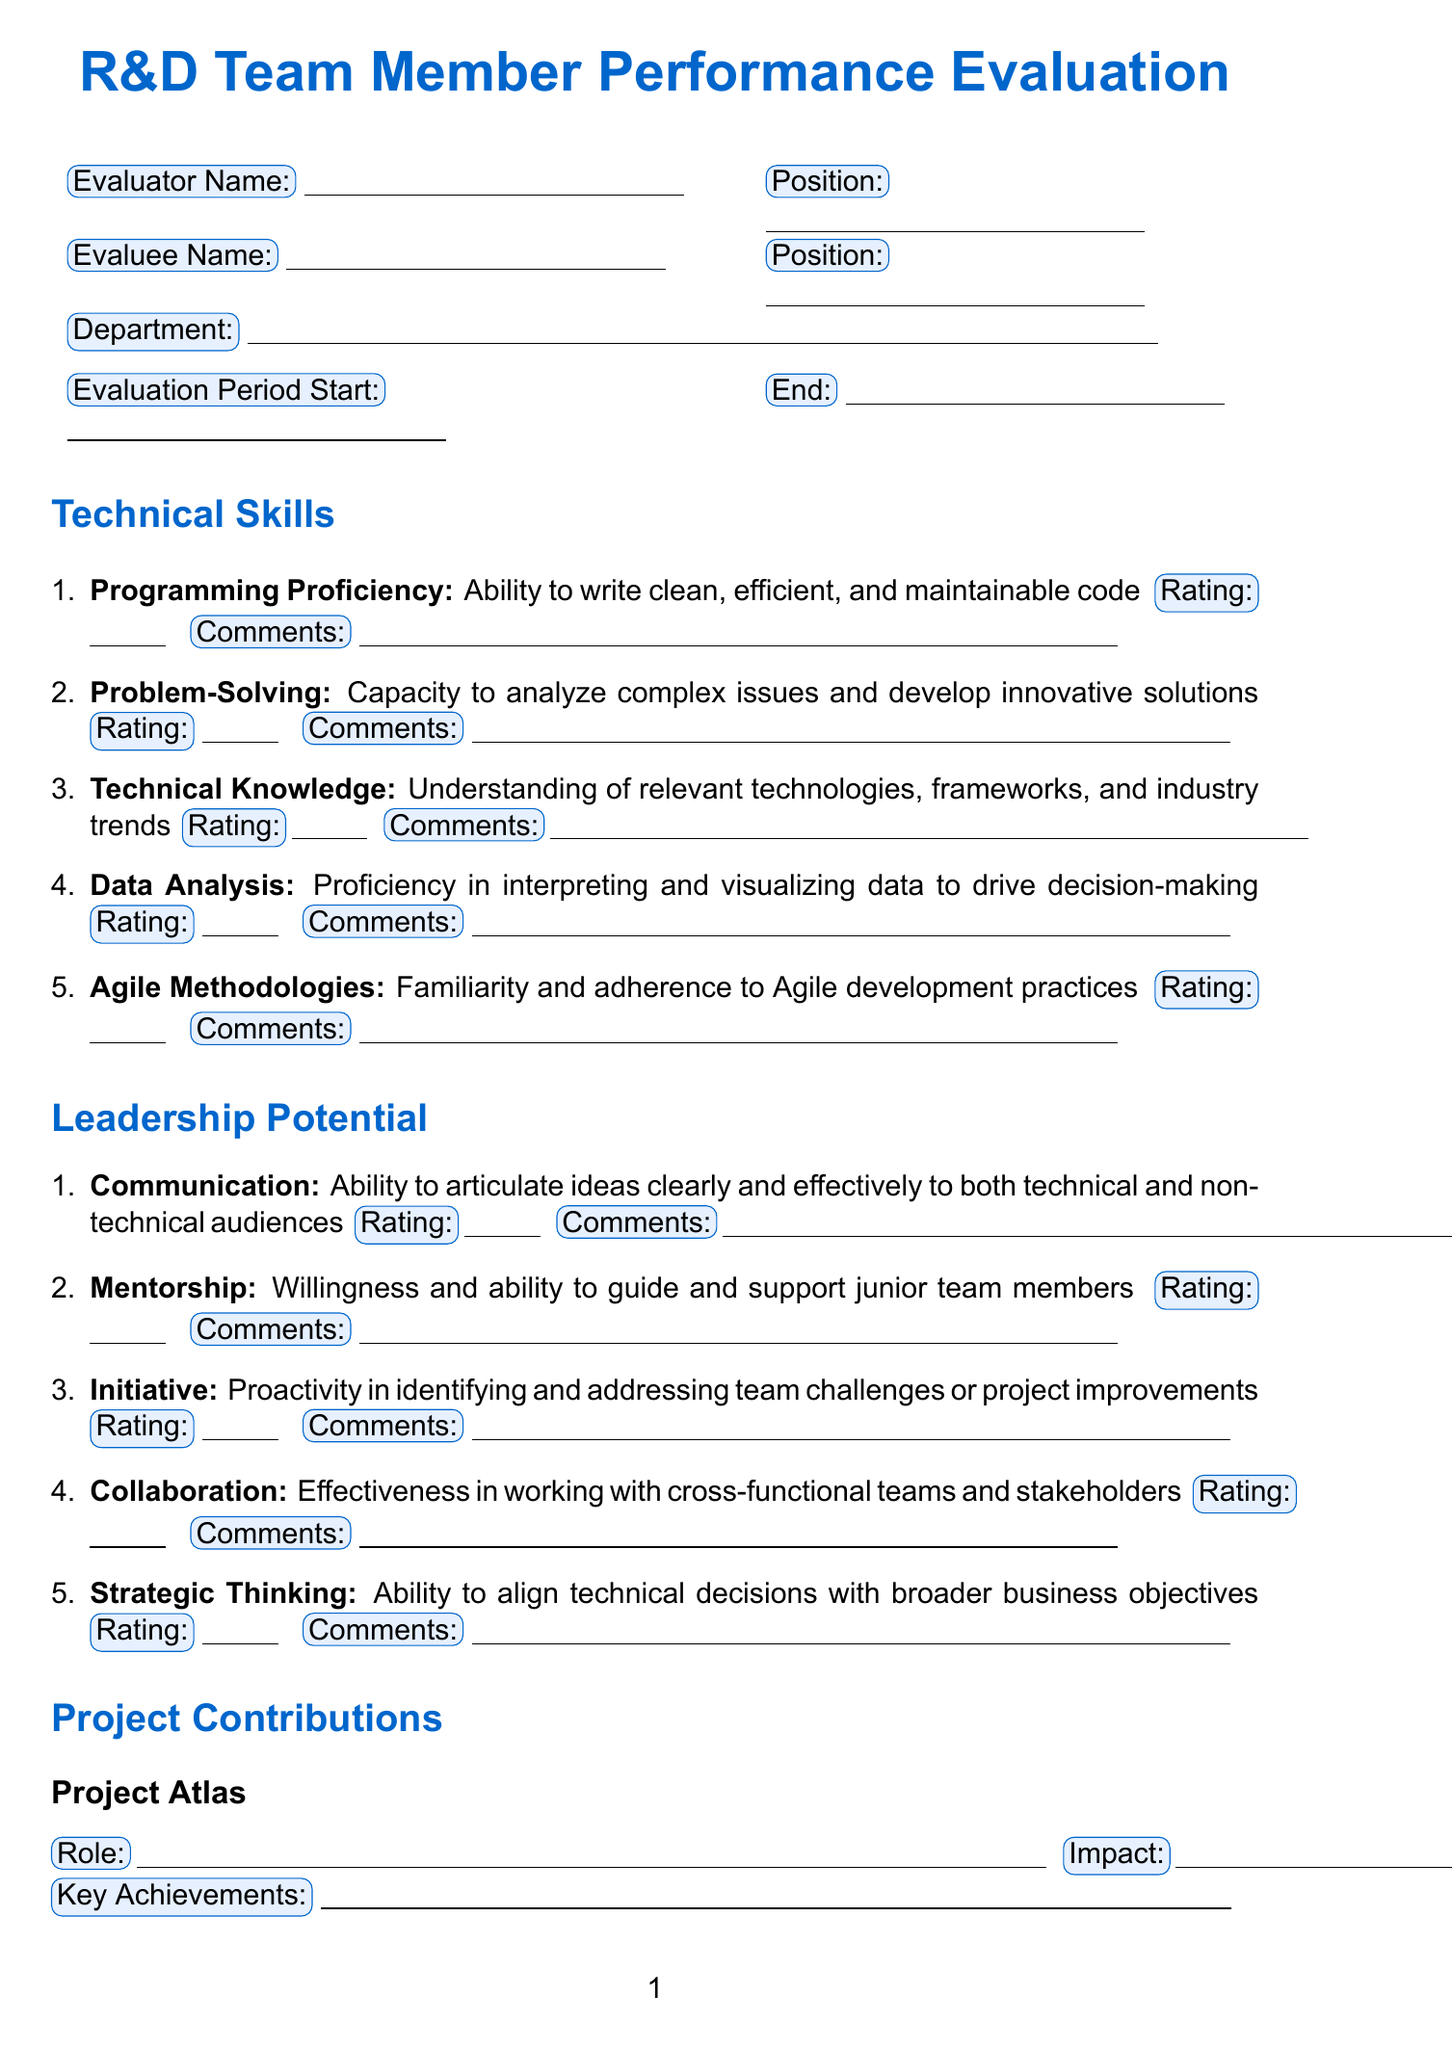What is the title of the form? The title of the form is presented at the start of the document and specifies its purpose.
Answer: R&D Team Member Performance Evaluation What department does the evaluee belong to? The department information is clearly indicated in the evaluated section of the document.
Answer: Research and Development What is the role of the evaluator? The position of the evaluator is listed in the evaluator information section of the document.
Answer: Junior Product Manager What rating corresponds to "Outstanding performance"? The rating scale provides a description for each score, including the one for outstanding performance.
Answer: 5 How many technical skills are listed for evaluation? The number of skills can be counted in the technical skills section of the document.
Answer: 5 Which project is named "Nexus Initiative"? The projects section lists both projects and identifies one by the given name.
Answer: Nexus Initiative What is the specific skill related to guiding junior team members? This information can be found in the leadership potential section, where specific skills are defined.
Answer: Mentorship What is expected to be assessed in the "Overall Performance" section? The overall performance section highlights categories that are evaluated for team member performance.
Answer: Strengths, Areas for Improvement, Goals for Next Period What is one area to provide additional comments? The document has a section specifically dedicated to extra comments that are not categorized elsewhere.
Answer: Additional Comments 